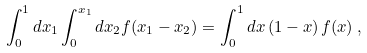<formula> <loc_0><loc_0><loc_500><loc_500>\int _ { 0 } ^ { 1 } d x _ { 1 } \int _ { 0 } ^ { x _ { 1 } } d x _ { 2 } f ( x _ { 1 } - x _ { 2 } ) = \int _ { 0 } ^ { 1 } d x \, ( 1 - x ) \, f ( x ) \, ,</formula> 